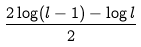Convert formula to latex. <formula><loc_0><loc_0><loc_500><loc_500>\frac { 2 \log ( l - 1 ) - \log l } { 2 }</formula> 